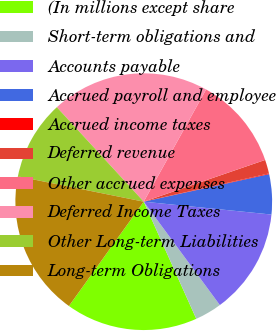Convert chart to OTSL. <chart><loc_0><loc_0><loc_500><loc_500><pie_chart><fcel>(In millions except share<fcel>Short-term obligations and<fcel>Accounts payable<fcel>Accrued payroll and employee<fcel>Accrued income taxes<fcel>Deferred revenue<fcel>Other accrued expenses<fcel>Deferred Income Taxes<fcel>Other Long-term Liabilities<fcel>Long-term Obligations<nl><fcel>16.61%<fcel>3.39%<fcel>13.3%<fcel>5.04%<fcel>0.09%<fcel>1.74%<fcel>11.65%<fcel>19.91%<fcel>10.0%<fcel>18.26%<nl></chart> 